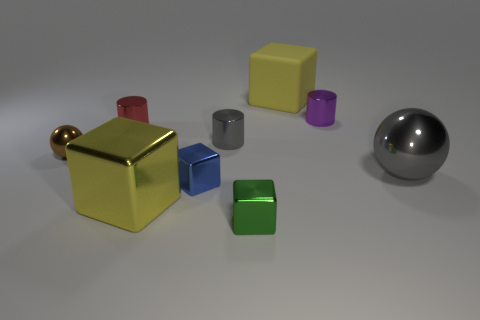Is the small gray object made of the same material as the large sphere?
Offer a very short reply. Yes. What number of objects are either large red objects or blue things?
Your response must be concise. 1. What is the size of the green metal cube?
Provide a short and direct response. Small. Are there fewer cyan balls than cylinders?
Offer a very short reply. Yes. How many tiny metallic objects are the same color as the rubber object?
Offer a very short reply. 0. There is a big thing behind the brown thing; does it have the same color as the small metallic sphere?
Make the answer very short. No. The big yellow object in front of the big gray metallic thing has what shape?
Offer a very short reply. Cube. There is a big gray thing right of the green metal cube; are there any gray cylinders that are left of it?
Give a very brief answer. Yes. What number of big blocks have the same material as the tiny brown thing?
Your answer should be very brief. 1. What is the size of the gray shiny thing to the left of the metal ball to the right of the ball on the left side of the small purple cylinder?
Offer a terse response. Small. 